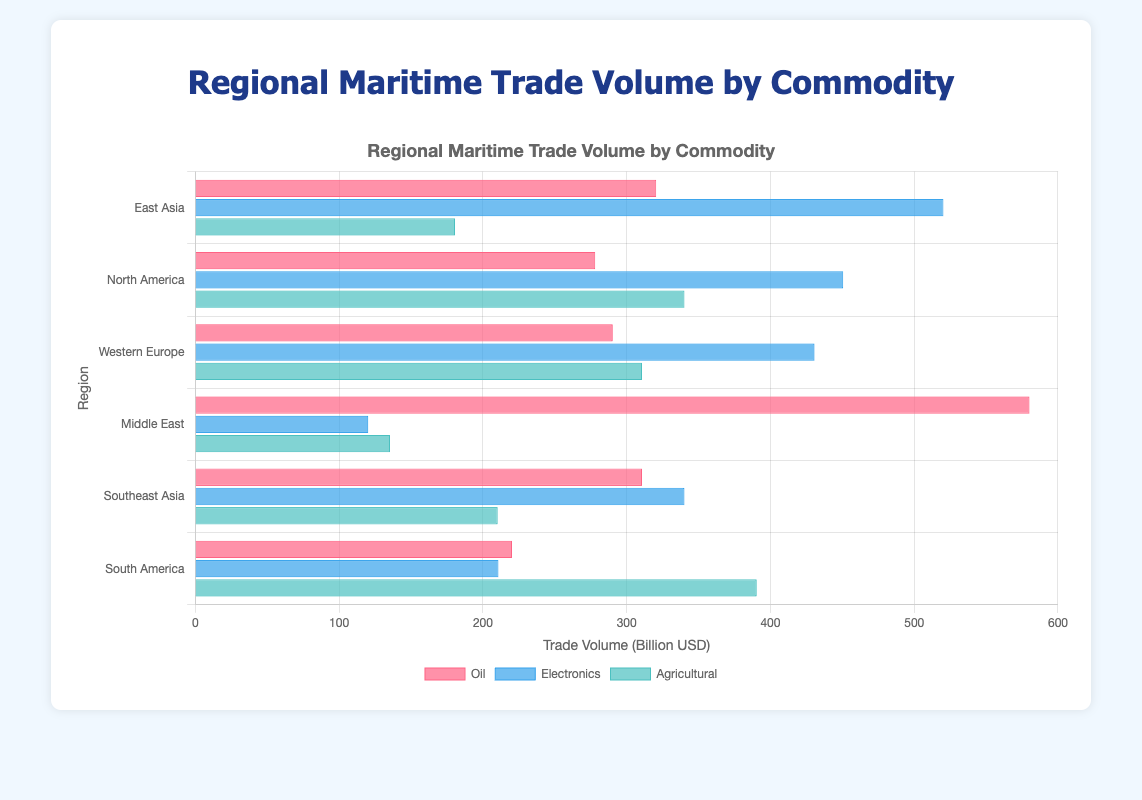Which region has the highest trade volume for oil? To find the region with the highest trade volume for oil, look at the height of the bars labeled "Oil" and identify the tallest one. The Middle East has the highest bar in the "Oil" category.
Answer: Middle East Compare the trade volumes of electronics and agricultural commodities in North America. Which is higher and by how much? Look at the heights of the bars for electronics and agricultural commodities in North America. The trade volume for electronics is 450.6, while for agricultural commodities, it is 340.2. Subtract the agricultural volume from the electronics volume (450.6 - 340.2).
Answer: Electronics, by 110.4 What is the total trade volume for all commodities in Western Europe? Sum the trade volumes for oil, electronics, and agricultural commodities in Western Europe (290.4 + 430.7 + 310.7).
Answer: 1031.8 Which region has the lowest trade volume for electronics? Look at the bars representing electronics for all regions and identify the shortest one. The Middle East has the shortest bar in the "Electronics" category.
Answer: Middle East For East Asia, how does the trade volume of agricultural commodities compare to electronics and oil? Compare the heights of the bars for agricultural, electronics, and oil for East Asia. Agriculture has 180.6, electronics has 520.3, and oil has 320.5. Electronics > Oil > Agriculture.
Answer: Agriculture < Oil < Electronics Calculate the average trade volume for agricultural commodities across all regions. Sum the trade volumes for agricultural commodities in all regions: (180.6 + 340.2 + 310.7 + 135.4 + 210.3 + 390.5) / 6.
Answer: 261.28 Which commodity has the smallest range in trade volumes across all regions? To determine the range, find the difference between the highest and lowest trade volumes for each commodity. Compare the ranges:
Oil: 580.2 - 220.3 = 359.9
Electronics: 520.3 - 120.3 = 400
Agricultural: 390.5 - 135.4 = 255.1
Agricultural has the smallest range.
Answer: Agricultural What is the trade volume difference between the highest and lowest regions for oil? Identify the highest and lowest trade volumes for oil, which are Middle East (580.2) and South America (220.3). Subtract the lowest from the highest (580.2 - 220.3).
Answer: 359.9 How does the trade volume of Southeast Asia for electronics compare with its agricultural trade volume? Look at the bars for electronics and agricultural in Southeast Asia. The trade volume for electronics is 340.2, and for agricultural, it is 210.3. Subtract agricultural volume from electronics volume (340.2 - 210.3).
Answer: Electronics is 129.9 higher than Agriculture 